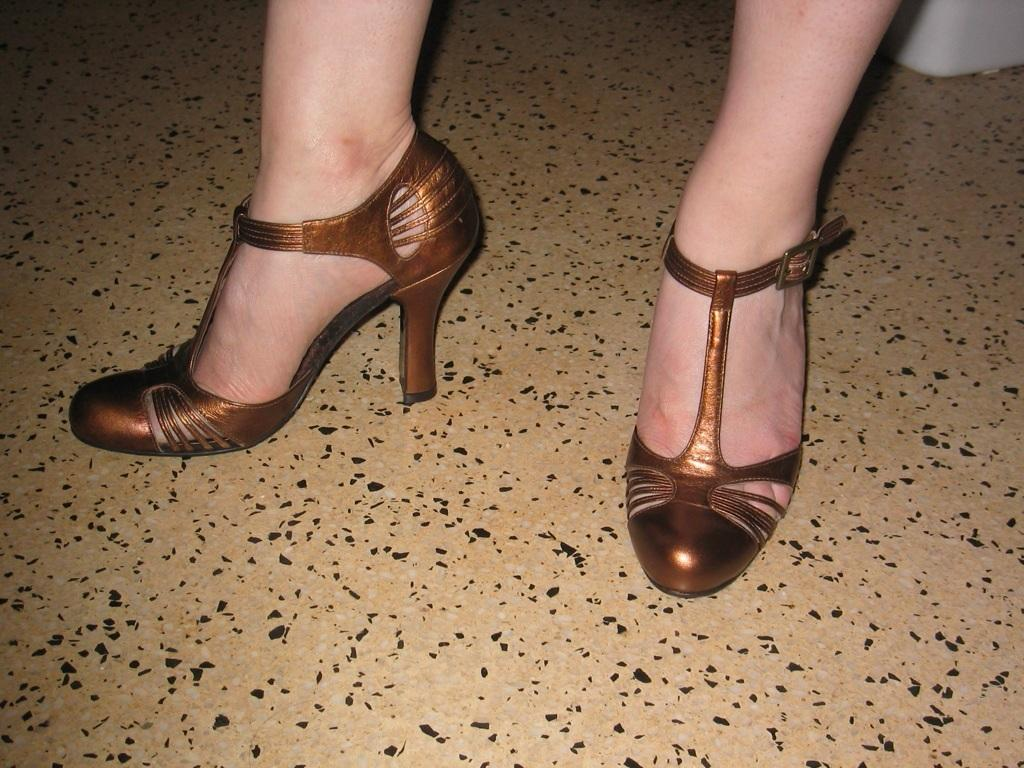What part of a person can be seen in the image? There are a person's legs in the image. What type of footwear is the person wearing? The person is wearing brown heels. What can be seen beneath the person's legs? The floor is visible in the image. Can you describe the white object in the image? There is a white object in the image, but its specific details are not clear from the provided facts. What type of activity is the person engaging in with their territory and table in the image? There is no mention of a territory or table in the image, and the person's activity cannot be determined from the provided facts. 